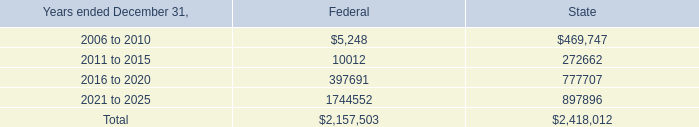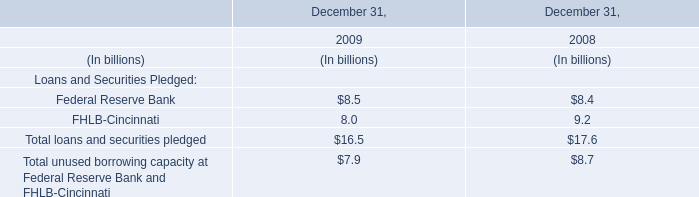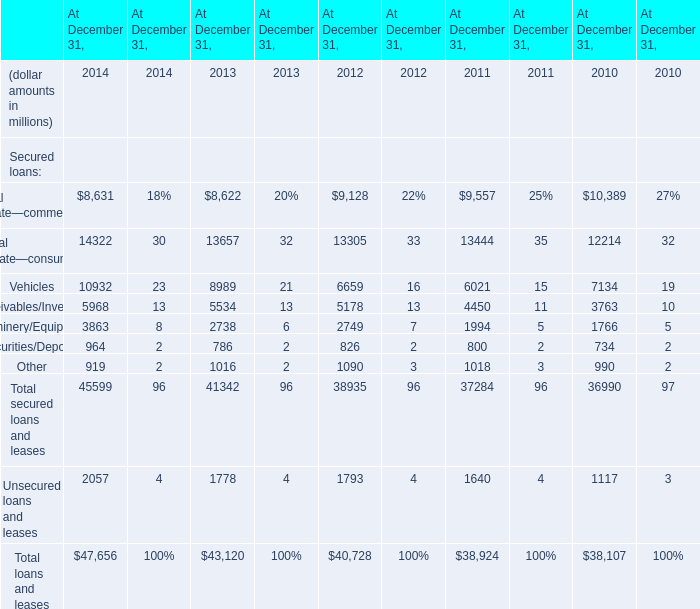What's the sum of Real estate—commercial of At December 31, 2012, 2016 to 2020 of Federal, and Vehicles of At December 31, 2013 ? 
Computations: ((9128.0 + 397691.0) + 8989.0)
Answer: 415808.0. 